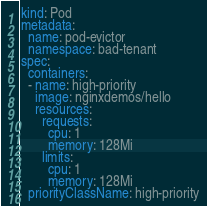Convert code to text. <code><loc_0><loc_0><loc_500><loc_500><_YAML_>kind: Pod
metadata:
  name: pod-evictor
  namespace: bad-tenant
spec:
  containers:
  - name: high-priority
    image: nginxdemos/hello
    resources:
      requests:
        cpu: 1
        memory: 128Mi
      limits:
        cpu: 1
        memory: 128Mi
  priorityClassName: high-priority

</code> 